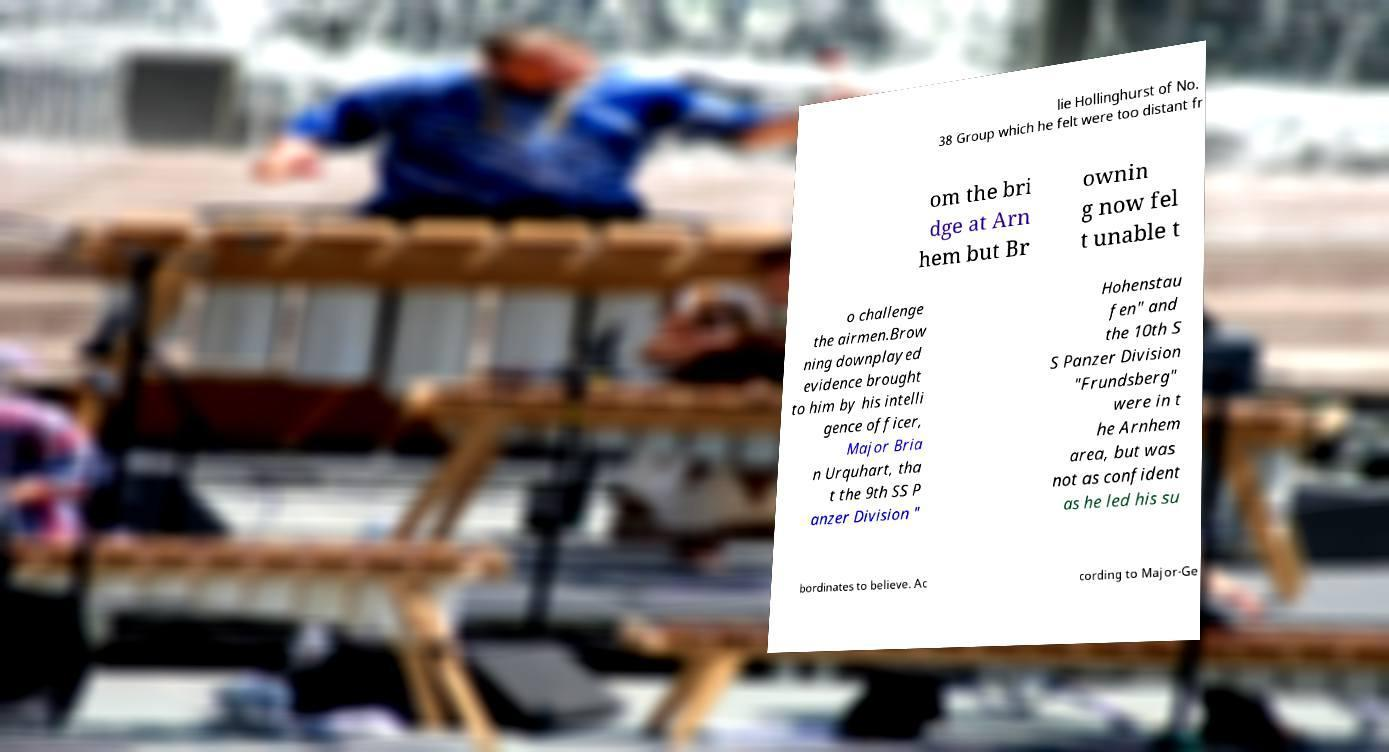Please read and relay the text visible in this image. What does it say? lie Hollinghurst of No. 38 Group which he felt were too distant fr om the bri dge at Arn hem but Br ownin g now fel t unable t o challenge the airmen.Brow ning downplayed evidence brought to him by his intelli gence officer, Major Bria n Urquhart, tha t the 9th SS P anzer Division " Hohenstau fen" and the 10th S S Panzer Division "Frundsberg" were in t he Arnhem area, but was not as confident as he led his su bordinates to believe. Ac cording to Major-Ge 